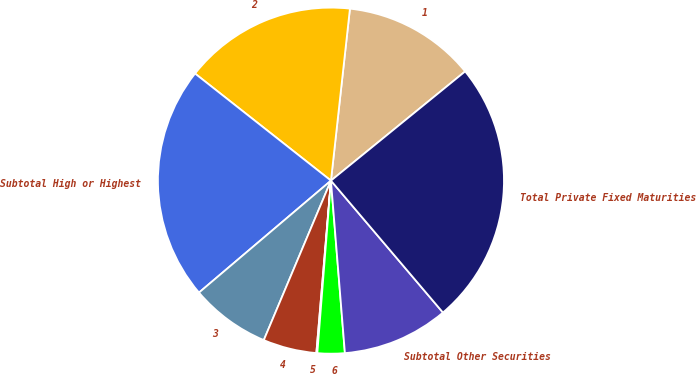Convert chart. <chart><loc_0><loc_0><loc_500><loc_500><pie_chart><fcel>1<fcel>2<fcel>Subtotal High or Highest<fcel>3<fcel>4<fcel>5<fcel>6<fcel>Subtotal Other Securities<fcel>Total Private Fixed Maturities<nl><fcel>12.38%<fcel>16.13%<fcel>21.82%<fcel>7.46%<fcel>5.0%<fcel>0.09%<fcel>2.54%<fcel>9.92%<fcel>24.67%<nl></chart> 